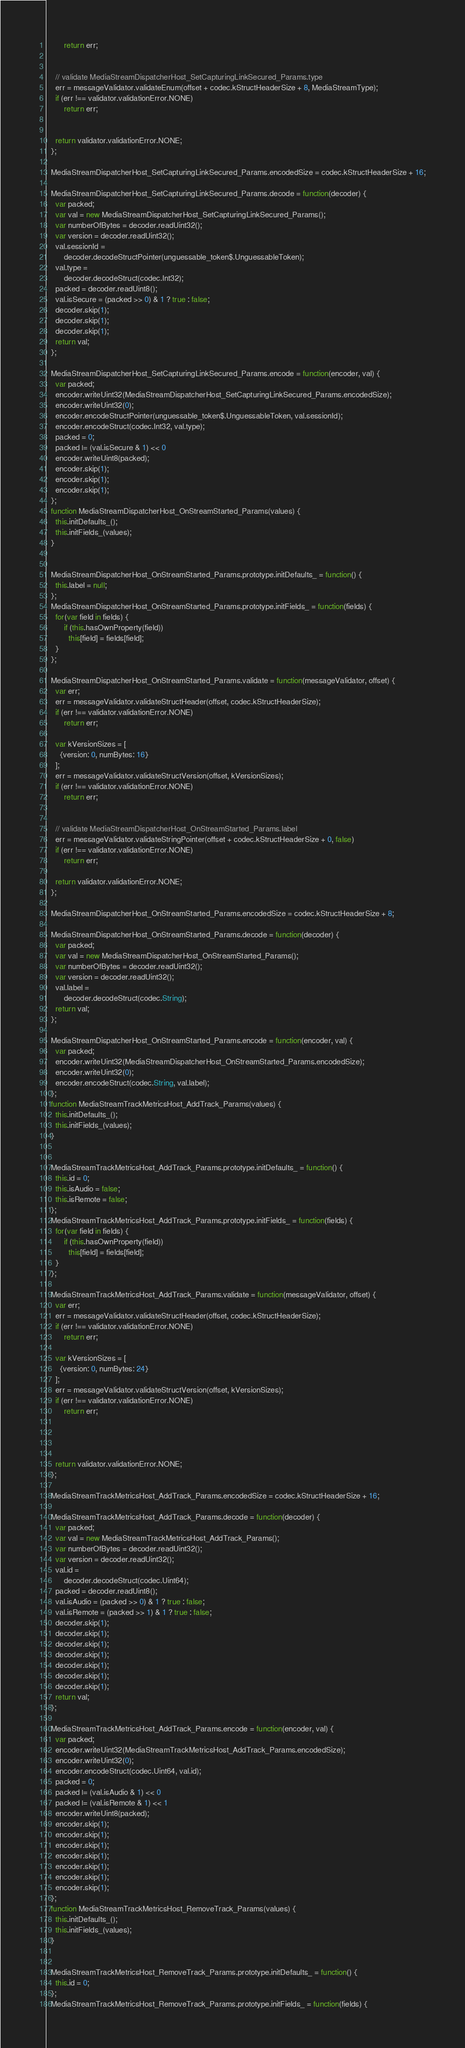Convert code to text. <code><loc_0><loc_0><loc_500><loc_500><_JavaScript_>        return err;


    // validate MediaStreamDispatcherHost_SetCapturingLinkSecured_Params.type
    err = messageValidator.validateEnum(offset + codec.kStructHeaderSize + 8, MediaStreamType);
    if (err !== validator.validationError.NONE)
        return err;


    return validator.validationError.NONE;
  };

  MediaStreamDispatcherHost_SetCapturingLinkSecured_Params.encodedSize = codec.kStructHeaderSize + 16;

  MediaStreamDispatcherHost_SetCapturingLinkSecured_Params.decode = function(decoder) {
    var packed;
    var val = new MediaStreamDispatcherHost_SetCapturingLinkSecured_Params();
    var numberOfBytes = decoder.readUint32();
    var version = decoder.readUint32();
    val.sessionId =
        decoder.decodeStructPointer(unguessable_token$.UnguessableToken);
    val.type =
        decoder.decodeStruct(codec.Int32);
    packed = decoder.readUint8();
    val.isSecure = (packed >> 0) & 1 ? true : false;
    decoder.skip(1);
    decoder.skip(1);
    decoder.skip(1);
    return val;
  };

  MediaStreamDispatcherHost_SetCapturingLinkSecured_Params.encode = function(encoder, val) {
    var packed;
    encoder.writeUint32(MediaStreamDispatcherHost_SetCapturingLinkSecured_Params.encodedSize);
    encoder.writeUint32(0);
    encoder.encodeStructPointer(unguessable_token$.UnguessableToken, val.sessionId);
    encoder.encodeStruct(codec.Int32, val.type);
    packed = 0;
    packed |= (val.isSecure & 1) << 0
    encoder.writeUint8(packed);
    encoder.skip(1);
    encoder.skip(1);
    encoder.skip(1);
  };
  function MediaStreamDispatcherHost_OnStreamStarted_Params(values) {
    this.initDefaults_();
    this.initFields_(values);
  }


  MediaStreamDispatcherHost_OnStreamStarted_Params.prototype.initDefaults_ = function() {
    this.label = null;
  };
  MediaStreamDispatcherHost_OnStreamStarted_Params.prototype.initFields_ = function(fields) {
    for(var field in fields) {
        if (this.hasOwnProperty(field))
          this[field] = fields[field];
    }
  };

  MediaStreamDispatcherHost_OnStreamStarted_Params.validate = function(messageValidator, offset) {
    var err;
    err = messageValidator.validateStructHeader(offset, codec.kStructHeaderSize);
    if (err !== validator.validationError.NONE)
        return err;

    var kVersionSizes = [
      {version: 0, numBytes: 16}
    ];
    err = messageValidator.validateStructVersion(offset, kVersionSizes);
    if (err !== validator.validationError.NONE)
        return err;


    // validate MediaStreamDispatcherHost_OnStreamStarted_Params.label
    err = messageValidator.validateStringPointer(offset + codec.kStructHeaderSize + 0, false)
    if (err !== validator.validationError.NONE)
        return err;

    return validator.validationError.NONE;
  };

  MediaStreamDispatcherHost_OnStreamStarted_Params.encodedSize = codec.kStructHeaderSize + 8;

  MediaStreamDispatcherHost_OnStreamStarted_Params.decode = function(decoder) {
    var packed;
    var val = new MediaStreamDispatcherHost_OnStreamStarted_Params();
    var numberOfBytes = decoder.readUint32();
    var version = decoder.readUint32();
    val.label =
        decoder.decodeStruct(codec.String);
    return val;
  };

  MediaStreamDispatcherHost_OnStreamStarted_Params.encode = function(encoder, val) {
    var packed;
    encoder.writeUint32(MediaStreamDispatcherHost_OnStreamStarted_Params.encodedSize);
    encoder.writeUint32(0);
    encoder.encodeStruct(codec.String, val.label);
  };
  function MediaStreamTrackMetricsHost_AddTrack_Params(values) {
    this.initDefaults_();
    this.initFields_(values);
  }


  MediaStreamTrackMetricsHost_AddTrack_Params.prototype.initDefaults_ = function() {
    this.id = 0;
    this.isAudio = false;
    this.isRemote = false;
  };
  MediaStreamTrackMetricsHost_AddTrack_Params.prototype.initFields_ = function(fields) {
    for(var field in fields) {
        if (this.hasOwnProperty(field))
          this[field] = fields[field];
    }
  };

  MediaStreamTrackMetricsHost_AddTrack_Params.validate = function(messageValidator, offset) {
    var err;
    err = messageValidator.validateStructHeader(offset, codec.kStructHeaderSize);
    if (err !== validator.validationError.NONE)
        return err;

    var kVersionSizes = [
      {version: 0, numBytes: 24}
    ];
    err = messageValidator.validateStructVersion(offset, kVersionSizes);
    if (err !== validator.validationError.NONE)
        return err;




    return validator.validationError.NONE;
  };

  MediaStreamTrackMetricsHost_AddTrack_Params.encodedSize = codec.kStructHeaderSize + 16;

  MediaStreamTrackMetricsHost_AddTrack_Params.decode = function(decoder) {
    var packed;
    var val = new MediaStreamTrackMetricsHost_AddTrack_Params();
    var numberOfBytes = decoder.readUint32();
    var version = decoder.readUint32();
    val.id =
        decoder.decodeStruct(codec.Uint64);
    packed = decoder.readUint8();
    val.isAudio = (packed >> 0) & 1 ? true : false;
    val.isRemote = (packed >> 1) & 1 ? true : false;
    decoder.skip(1);
    decoder.skip(1);
    decoder.skip(1);
    decoder.skip(1);
    decoder.skip(1);
    decoder.skip(1);
    decoder.skip(1);
    return val;
  };

  MediaStreamTrackMetricsHost_AddTrack_Params.encode = function(encoder, val) {
    var packed;
    encoder.writeUint32(MediaStreamTrackMetricsHost_AddTrack_Params.encodedSize);
    encoder.writeUint32(0);
    encoder.encodeStruct(codec.Uint64, val.id);
    packed = 0;
    packed |= (val.isAudio & 1) << 0
    packed |= (val.isRemote & 1) << 1
    encoder.writeUint8(packed);
    encoder.skip(1);
    encoder.skip(1);
    encoder.skip(1);
    encoder.skip(1);
    encoder.skip(1);
    encoder.skip(1);
    encoder.skip(1);
  };
  function MediaStreamTrackMetricsHost_RemoveTrack_Params(values) {
    this.initDefaults_();
    this.initFields_(values);
  }


  MediaStreamTrackMetricsHost_RemoveTrack_Params.prototype.initDefaults_ = function() {
    this.id = 0;
  };
  MediaStreamTrackMetricsHost_RemoveTrack_Params.prototype.initFields_ = function(fields) {</code> 